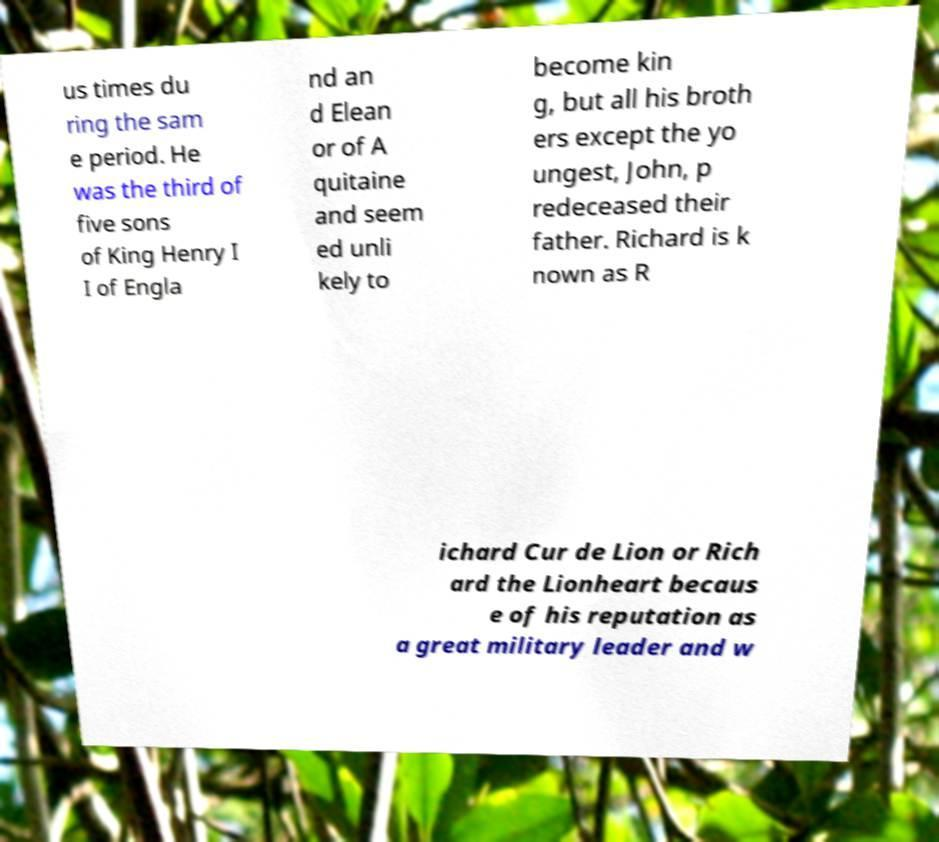I need the written content from this picture converted into text. Can you do that? us times du ring the sam e period. He was the third of five sons of King Henry I I of Engla nd an d Elean or of A quitaine and seem ed unli kely to become kin g, but all his broth ers except the yo ungest, John, p redeceased their father. Richard is k nown as R ichard Cur de Lion or Rich ard the Lionheart becaus e of his reputation as a great military leader and w 